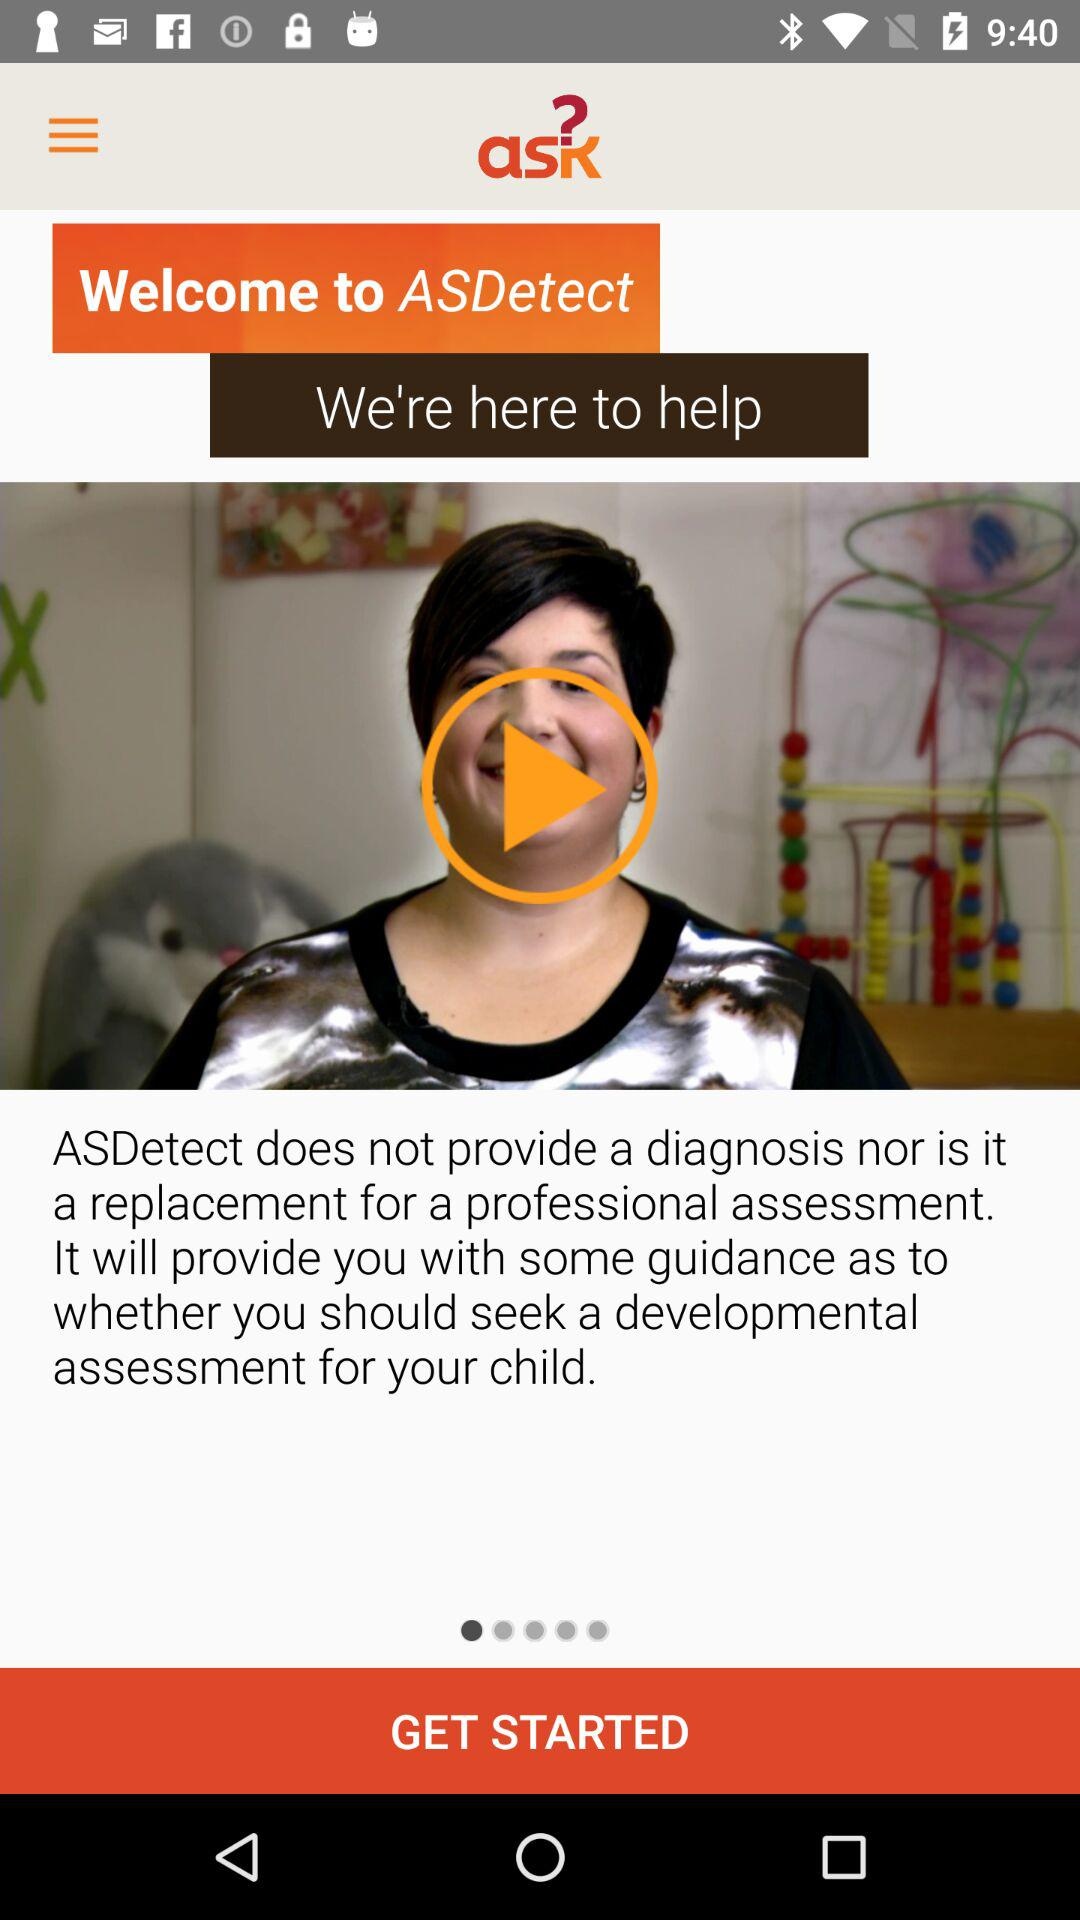What is the name of the application? The name of the application is "ASDetect". 